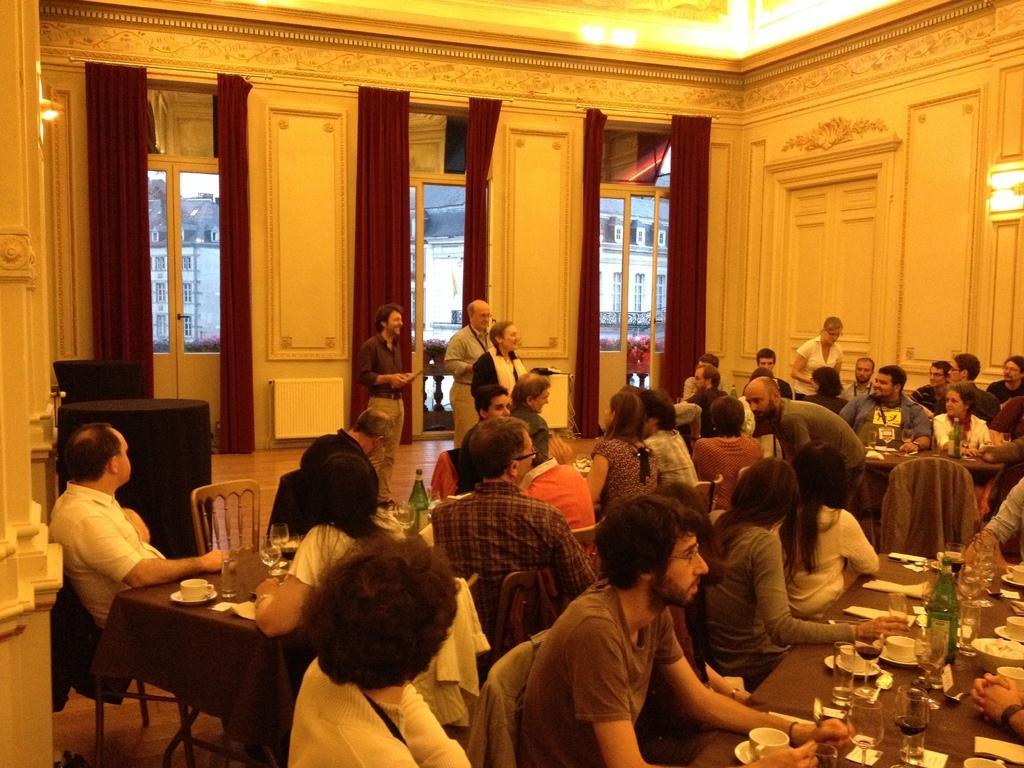In one or two sentences, can you explain what this image depicts? On the background of the picture we can see doors through which outside view is visible and they are buildings. These are curtains in red colour. Here we can see few persons standing. This is a floor. Here we can all the persons sitting on the chairs in front of a table. On the table we can see cup and saucers, glasses, bottle. 